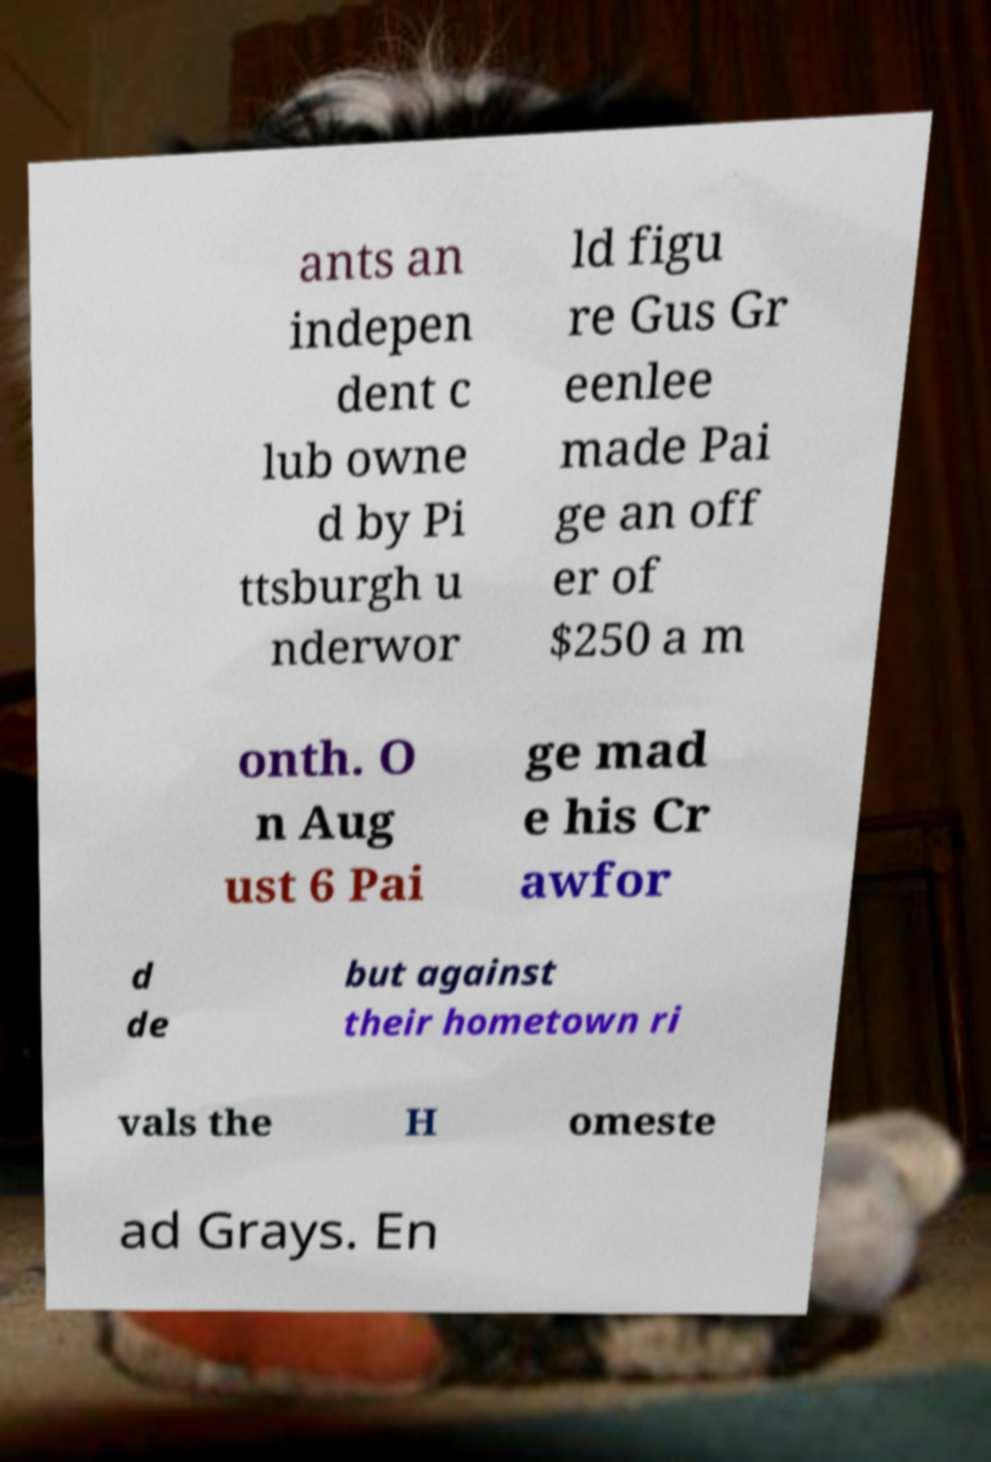Could you extract and type out the text from this image? ants an indepen dent c lub owne d by Pi ttsburgh u nderwor ld figu re Gus Gr eenlee made Pai ge an off er of $250 a m onth. O n Aug ust 6 Pai ge mad e his Cr awfor d de but against their hometown ri vals the H omeste ad Grays. En 